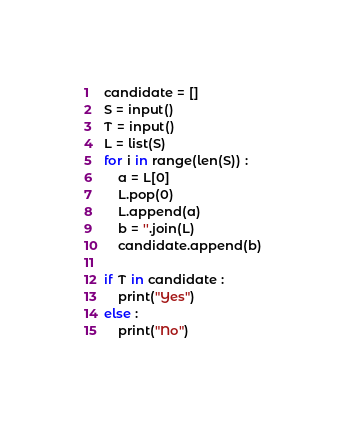Convert code to text. <code><loc_0><loc_0><loc_500><loc_500><_Python_>candidate = []
S = input()
T = input()
L = list(S)
for i in range(len(S)) :
    a = L[0]
    L.pop(0)
    L.append(a)
    b = ''.join(L)
    candidate.append(b)

if T in candidate :
    print("Yes")
else :
    print("No")

</code> 